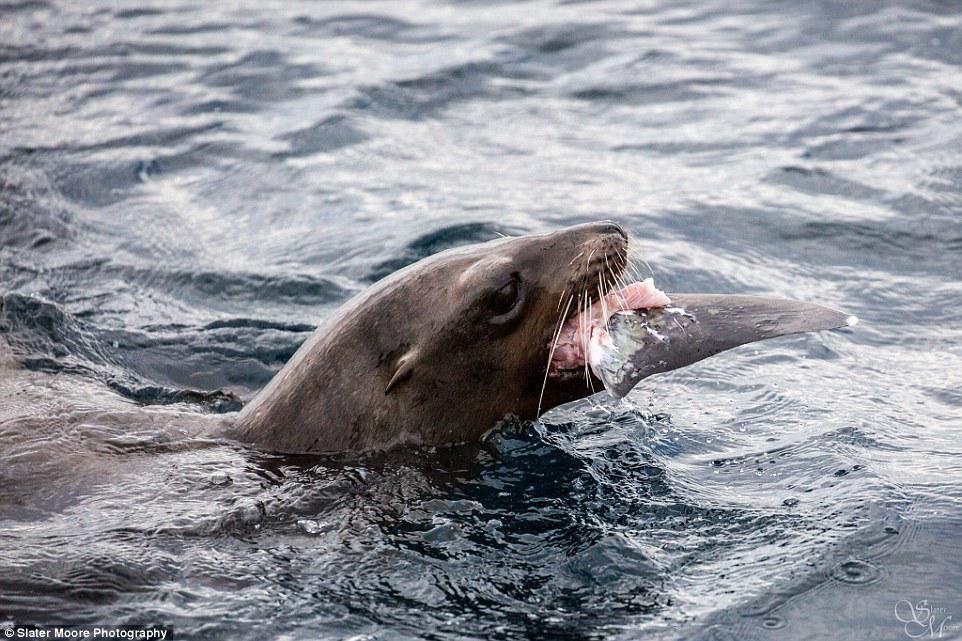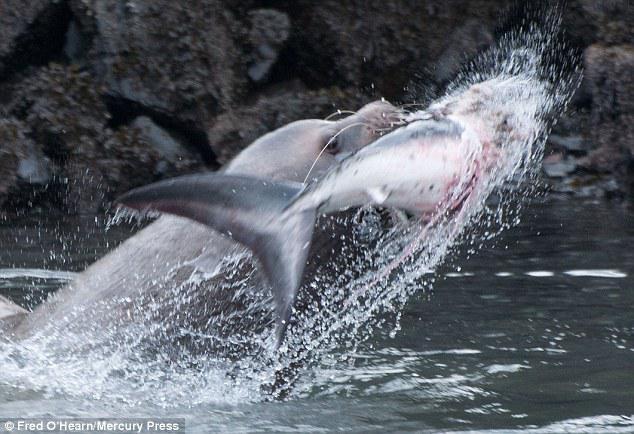The first image is the image on the left, the second image is the image on the right. For the images displayed, is the sentence "The seal in the left image is facing left with food in its mouth." factually correct? Answer yes or no. No. The first image is the image on the left, the second image is the image on the right. Evaluate the accuracy of this statement regarding the images: "All of the images contains only animals and water and nothing else.". Is it true? Answer yes or no. No. 